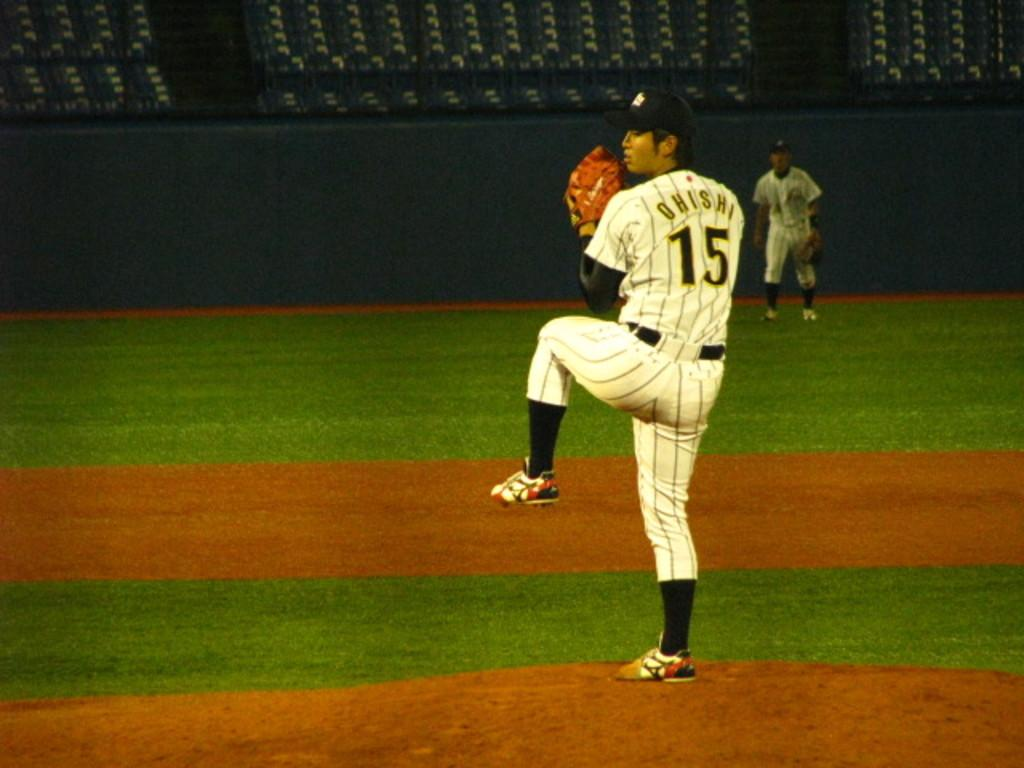<image>
Offer a succinct explanation of the picture presented. The player, Ohishi, is pitching at the baseball game 